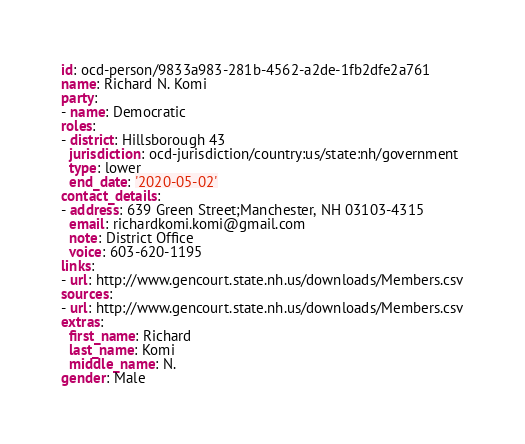<code> <loc_0><loc_0><loc_500><loc_500><_YAML_>id: ocd-person/9833a983-281b-4562-a2de-1fb2dfe2a761
name: Richard N. Komi
party:
- name: Democratic
roles:
- district: Hillsborough 43
  jurisdiction: ocd-jurisdiction/country:us/state:nh/government
  type: lower
  end_date: '2020-05-02'
contact_details:
- address: 639 Green Street;Manchester, NH 03103-4315
  email: richardkomi.komi@gmail.com
  note: District Office
  voice: 603-620-1195
links:
- url: http://www.gencourt.state.nh.us/downloads/Members.csv
sources:
- url: http://www.gencourt.state.nh.us/downloads/Members.csv
extras:
  first_name: Richard
  last_name: Komi
  middle_name: N.
gender: Male
</code> 